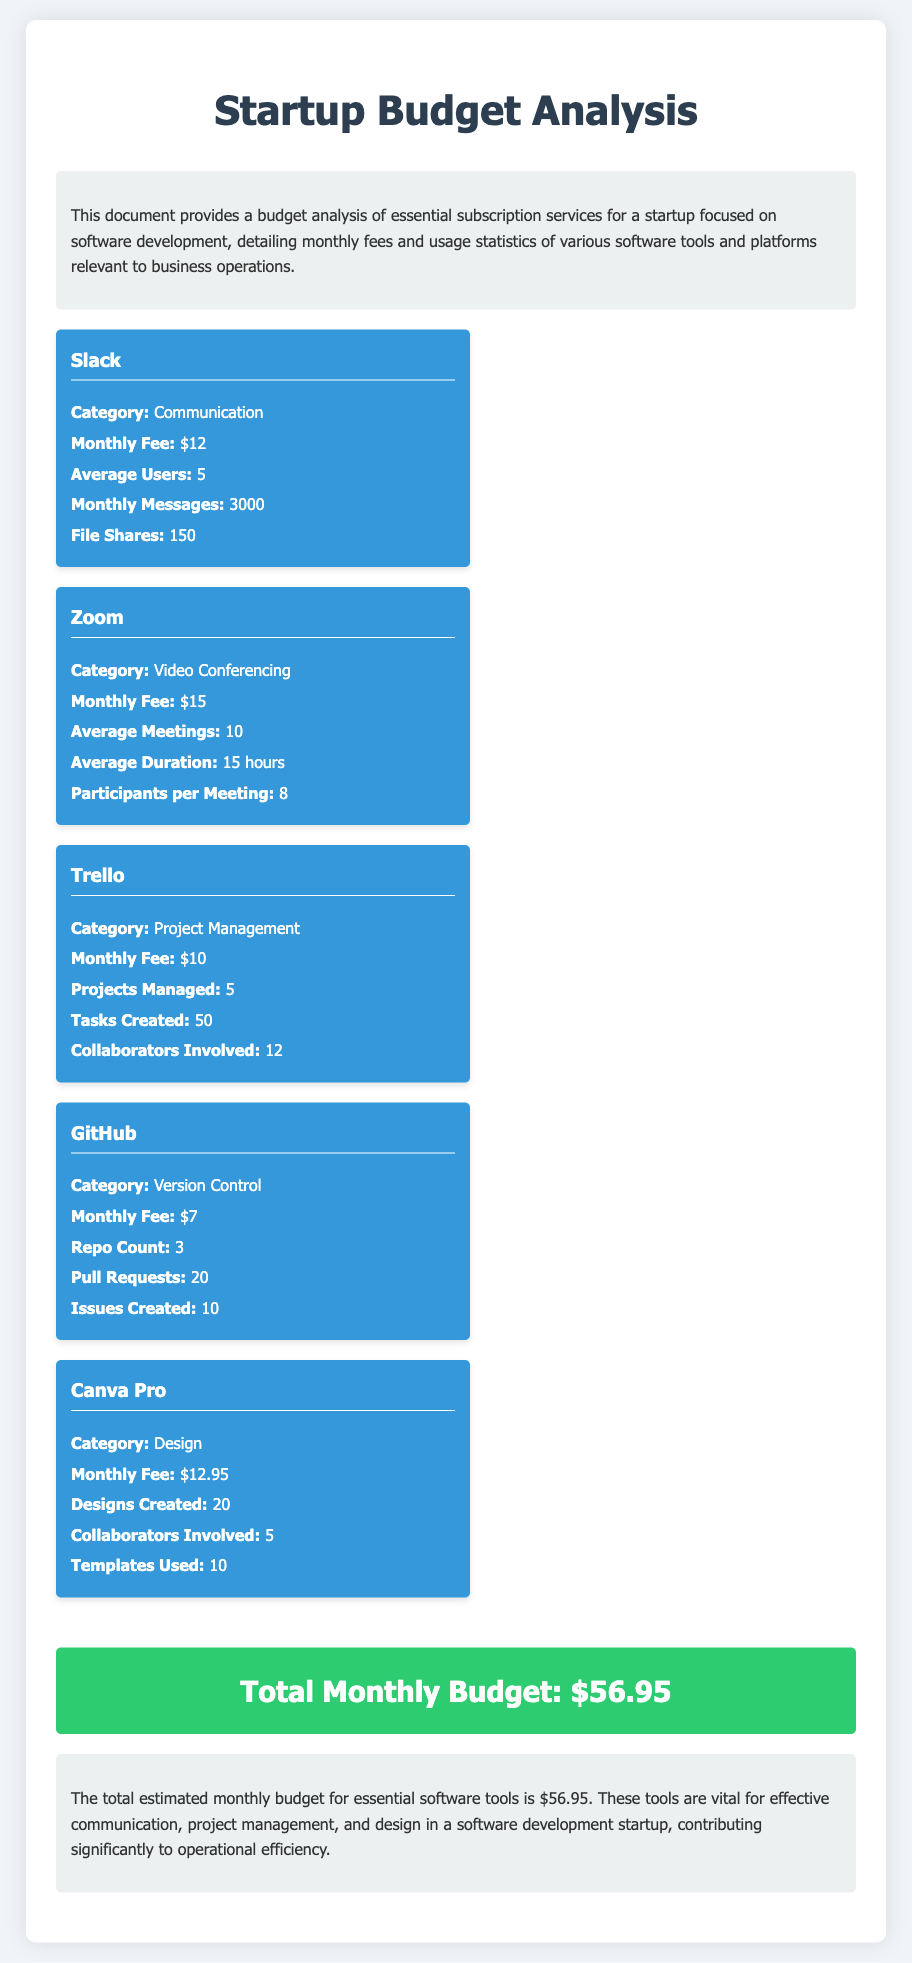What is the total monthly budget? The total monthly budget is summarized in the conclusion section, which states the total as $56.95.
Answer: $56.95 How many average users does Slack have? Slack's average user count is mentioned under its section, which specifies that there are 5 average users.
Answer: 5 What is the monthly fee for GitHub? The monthly fee for GitHub is provided as part of its details, which is $7.
Answer: $7 How many designs are created with Canva Pro monthly? The number of designs created is mentioned in the Canva Pro section, stating 20 designs are created monthly.
Answer: 20 What category does Zoom fall under? Zoom's category is indicated in its section as Video Conferencing.
Answer: Video Conferencing What is the average duration of meetings on Zoom? The average duration for Zoom meetings is specified as 15 hours in its details section.
Answer: 15 hours How many projects are managed with Trello? Trello states that 5 projects are managed, which can be found in its specific section.
Answer: 5 What type of software tool is GitHub? GitHub's classification is provided in its section as Version Control.
Answer: Version Control How many file shares does Slack have? Slack's section specifies that there are 150 file shares recorded.
Answer: 150 